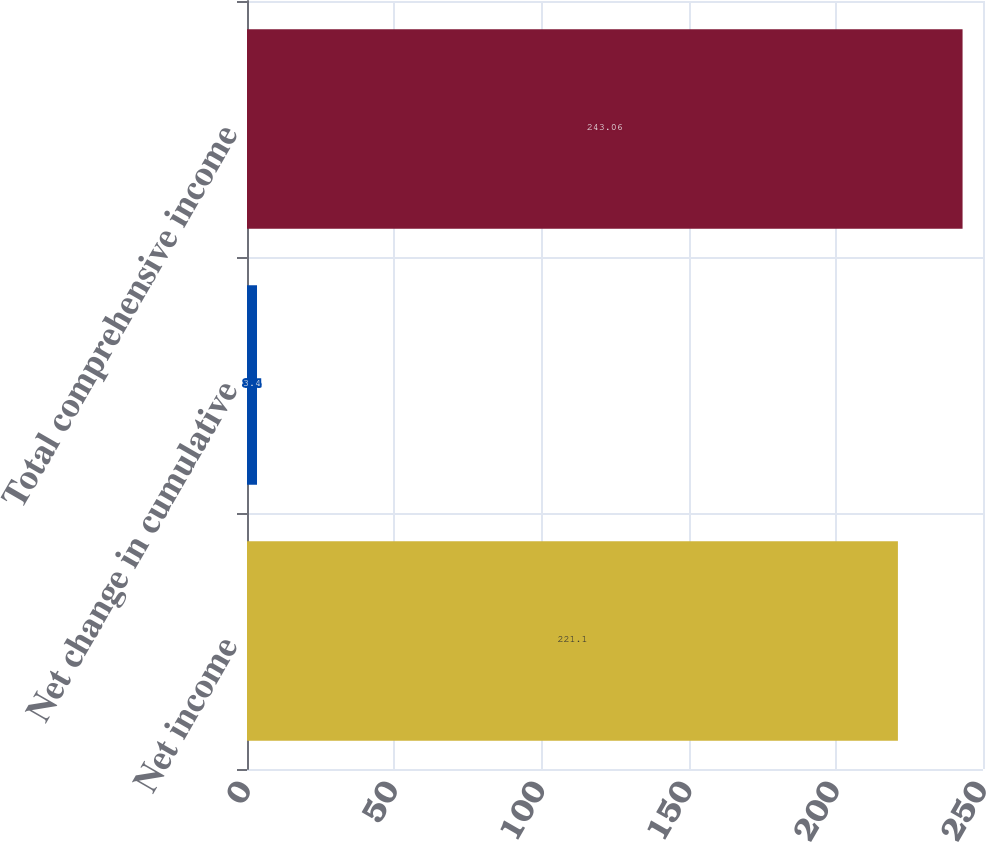Convert chart to OTSL. <chart><loc_0><loc_0><loc_500><loc_500><bar_chart><fcel>Net income<fcel>Net change in cumulative<fcel>Total comprehensive income<nl><fcel>221.1<fcel>3.4<fcel>243.06<nl></chart> 